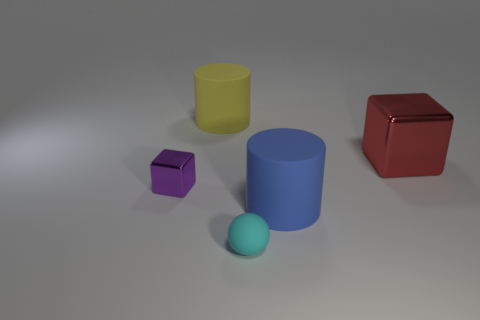Add 3 blue rubber cylinders. How many objects exist? 8 Subtract all balls. How many objects are left? 4 Subtract 0 purple balls. How many objects are left? 5 Subtract all small green metal balls. Subtract all big blue rubber cylinders. How many objects are left? 4 Add 4 tiny purple blocks. How many tiny purple blocks are left? 5 Add 5 blue things. How many blue things exist? 6 